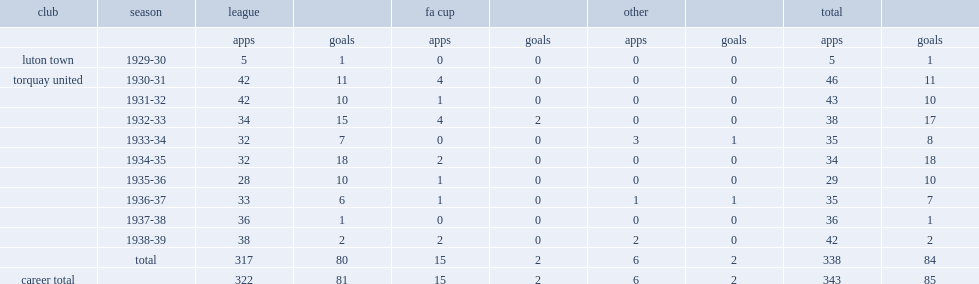What was the number of appearances made by hutchinson for torquay totally? 338.0. 